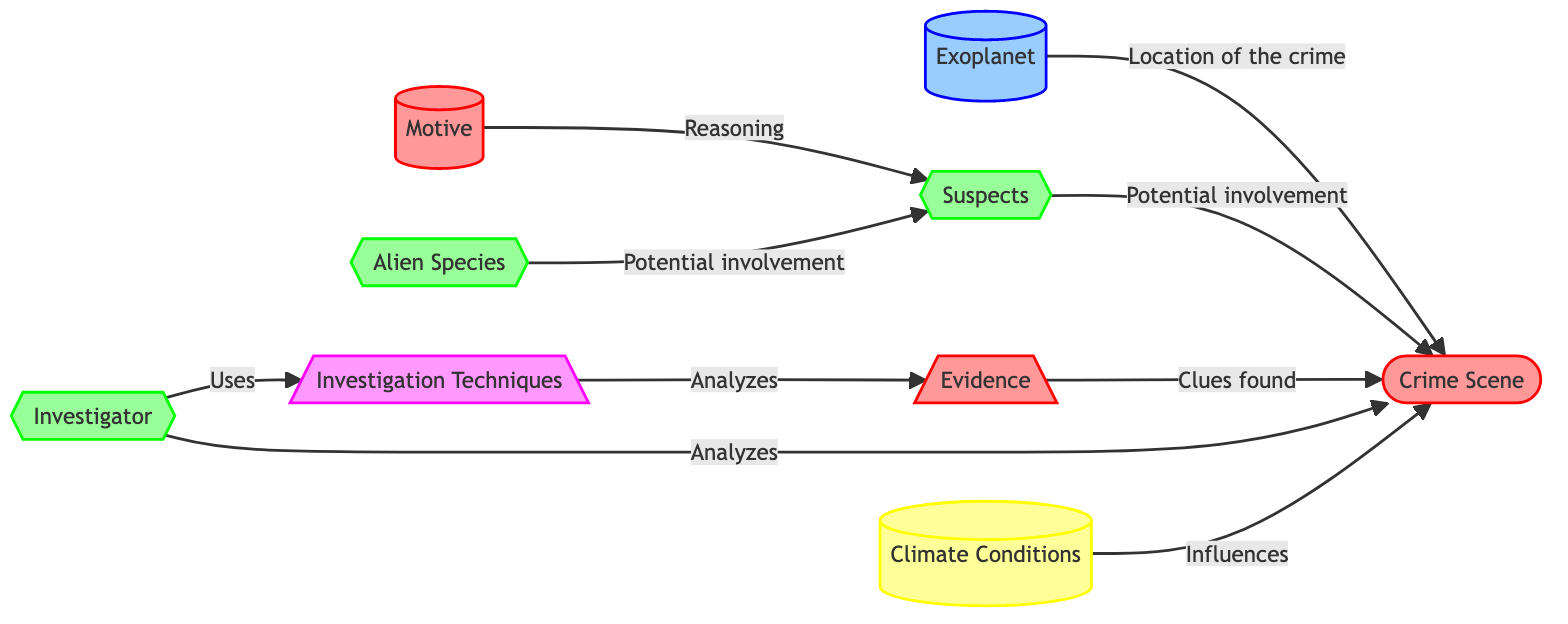What is the central node of the diagram? The central node in this diagram is labeled "Crime Scene," which is the primary focus of the analysis around hypothetical crime scenes on exoplanets.
Answer: Crime Scene How many actor elements are shown in the diagram? The diagram includes three actor elements: "Suspects," "Investigator," and "Alien Species." Counting these reveals a total of three.
Answer: 3 What is the relationship between "Suspects" and "Motive"? The diagram indicates that "Motive" provides the reasoning behind the "Suspects," suggesting that suspects are influenced by a motive.
Answer: Reasoning Which element influences the "Crime Scene"? The diagram shows that "Climate Conditions" influence the "Crime Scene," indicating that environmental factors can affect the nature of the crime.
Answer: Climate Conditions What are the investigation techniques used by the "Investigator"? "Investigation Techniques" are listed as an element utilized by the "Investigator" to analyze the evidence found at the crime scene.
Answer: Investigation Techniques Why might "Alien Species" be involved in the crime? According to the diagram, "Alien Species" are mentioned as having potential involvement with the "Suspects," which infers that they could be connected to the crime or suspects.
Answer: Potential involvement What leads to the analysis of the "Crime Scene" by the Investigator? The two main relationships leading to this action are that the "Investigator" analyzes the "Crime Scene" and uses "Investigation Techniques" to analyze the "Evidence." This indicates an integrated approach to solving the crime.
Answer: Crime Scene How many nodes are directly related to the "Crime Scene"? Four nodes are directly related to the "Crime Scene": "Exoplanet," "Suspects," "Evidence," and "Climate Conditions." Counting these gives a total of four nodes.
Answer: 4 What influences the "Investigator's" techniques according to the diagram? The diagram does not directly mention any influences on the "Investigator’s" techniques, but it implies that the "Techniques" are used by the "Investigator" to analyze suspect evidence. Thus, the connection relies on the "Investigator's" role in the investigation.
Answer: Investigative Role 